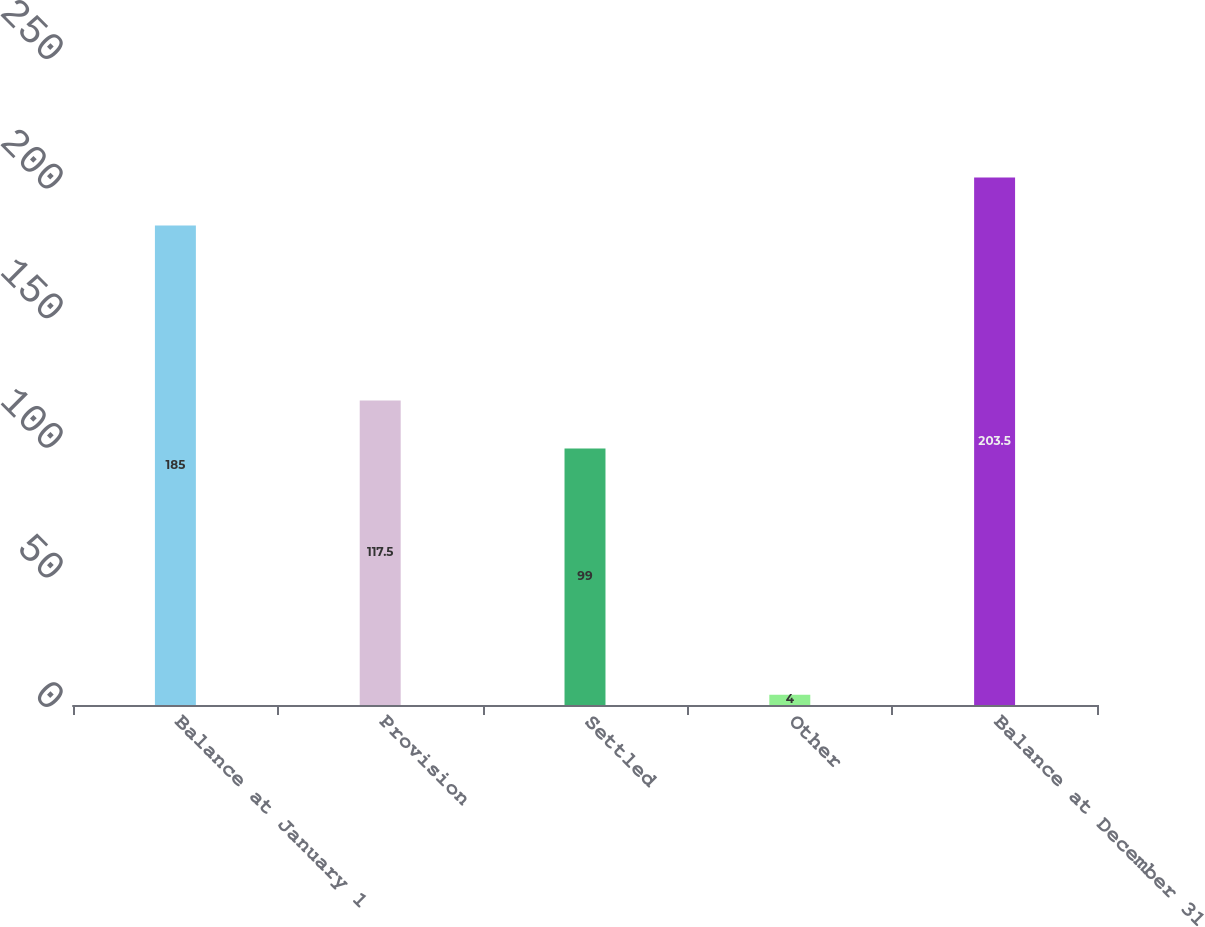<chart> <loc_0><loc_0><loc_500><loc_500><bar_chart><fcel>Balance at January 1<fcel>Provision<fcel>Settled<fcel>Other<fcel>Balance at December 31<nl><fcel>185<fcel>117.5<fcel>99<fcel>4<fcel>203.5<nl></chart> 